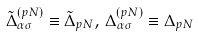<formula> <loc_0><loc_0><loc_500><loc_500>\tilde { \Delta } ^ { ( p N ) } _ { \alpha \sigma } \equiv \tilde { \Delta } _ { p N } , \, \Delta ^ { ( p N ) } _ { \alpha \sigma } \equiv \Delta _ { p N }</formula> 